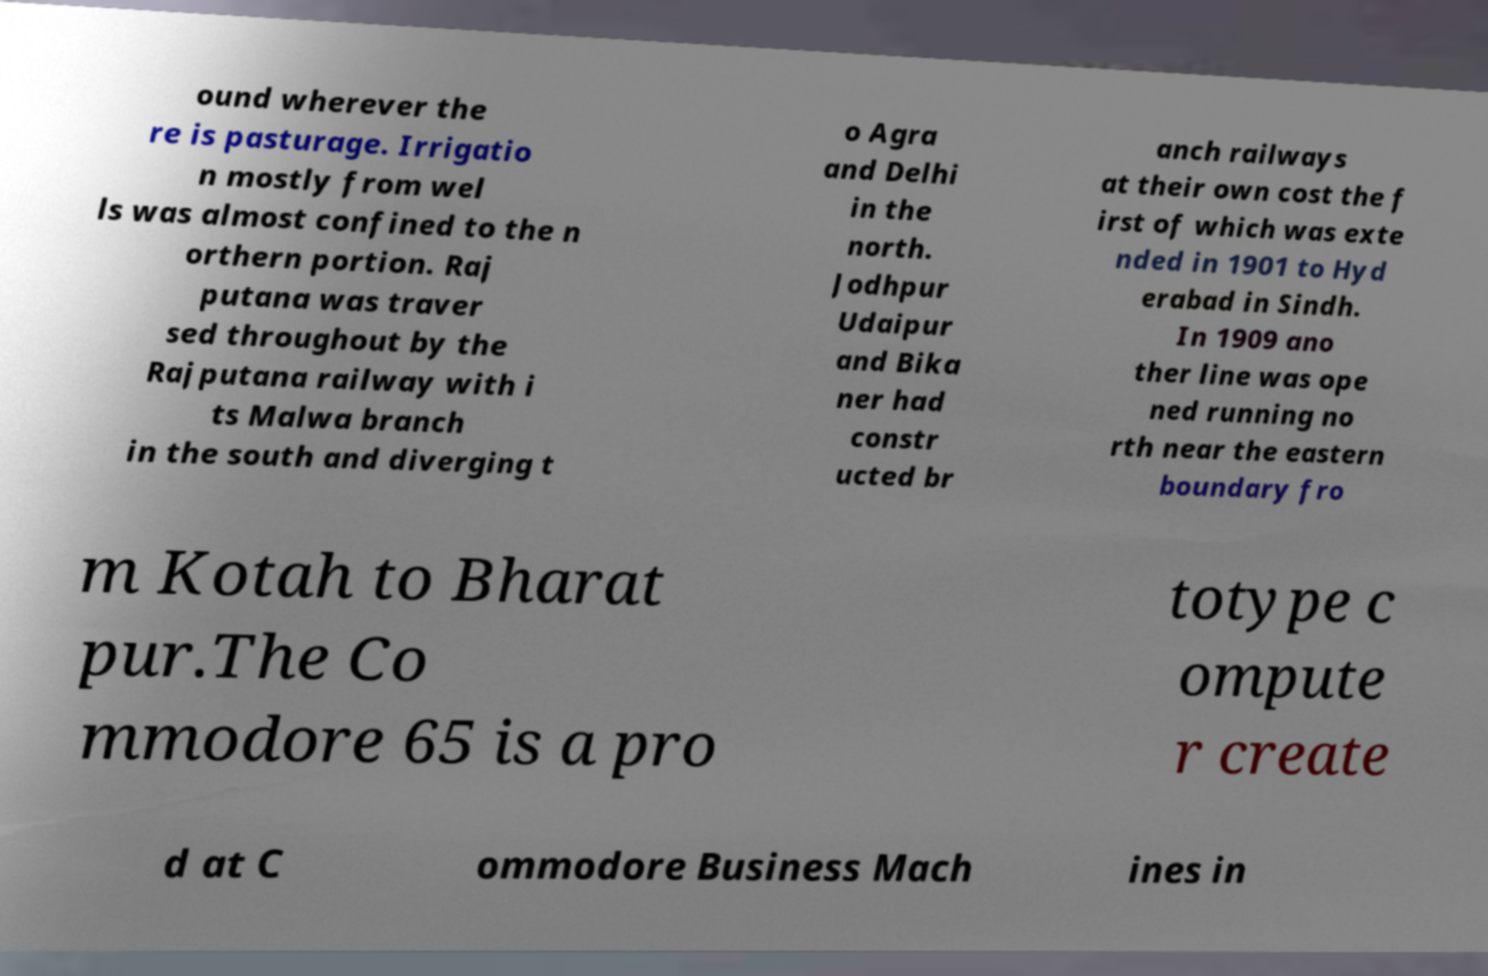What messages or text are displayed in this image? I need them in a readable, typed format. ound wherever the re is pasturage. Irrigatio n mostly from wel ls was almost confined to the n orthern portion. Raj putana was traver sed throughout by the Rajputana railway with i ts Malwa branch in the south and diverging t o Agra and Delhi in the north. Jodhpur Udaipur and Bika ner had constr ucted br anch railways at their own cost the f irst of which was exte nded in 1901 to Hyd erabad in Sindh. In 1909 ano ther line was ope ned running no rth near the eastern boundary fro m Kotah to Bharat pur.The Co mmodore 65 is a pro totype c ompute r create d at C ommodore Business Mach ines in 